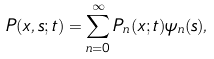<formula> <loc_0><loc_0><loc_500><loc_500>P ( x , s ; t ) = \sum _ { n = 0 } ^ { \infty } P _ { n } ( x ; t ) \psi _ { n } ( s ) ,</formula> 